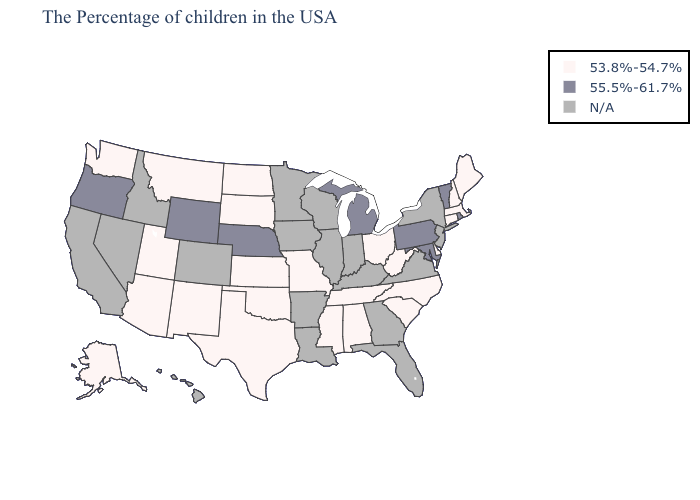Does the map have missing data?
Concise answer only. Yes. Name the states that have a value in the range 53.8%-54.7%?
Short answer required. Maine, Massachusetts, New Hampshire, Connecticut, Delaware, North Carolina, South Carolina, West Virginia, Ohio, Alabama, Tennessee, Mississippi, Missouri, Kansas, Oklahoma, Texas, South Dakota, North Dakota, New Mexico, Utah, Montana, Arizona, Washington, Alaska. Does Connecticut have the lowest value in the Northeast?
Keep it brief. Yes. Name the states that have a value in the range N/A?
Keep it brief. New York, New Jersey, Virginia, Florida, Georgia, Kentucky, Indiana, Wisconsin, Illinois, Louisiana, Arkansas, Minnesota, Iowa, Colorado, Idaho, Nevada, California, Hawaii. Does Delaware have the highest value in the USA?
Short answer required. No. Does North Carolina have the highest value in the USA?
Keep it brief. No. What is the value of Maryland?
Short answer required. 55.5%-61.7%. Does Wyoming have the highest value in the West?
Short answer required. Yes. Does Wyoming have the highest value in the West?
Be succinct. Yes. What is the value of North Dakota?
Concise answer only. 53.8%-54.7%. What is the highest value in states that border Vermont?
Be succinct. 53.8%-54.7%. What is the lowest value in states that border Idaho?
Write a very short answer. 53.8%-54.7%. Which states hav the highest value in the MidWest?
Give a very brief answer. Michigan, Nebraska. What is the highest value in the MidWest ?
Give a very brief answer. 55.5%-61.7%. 